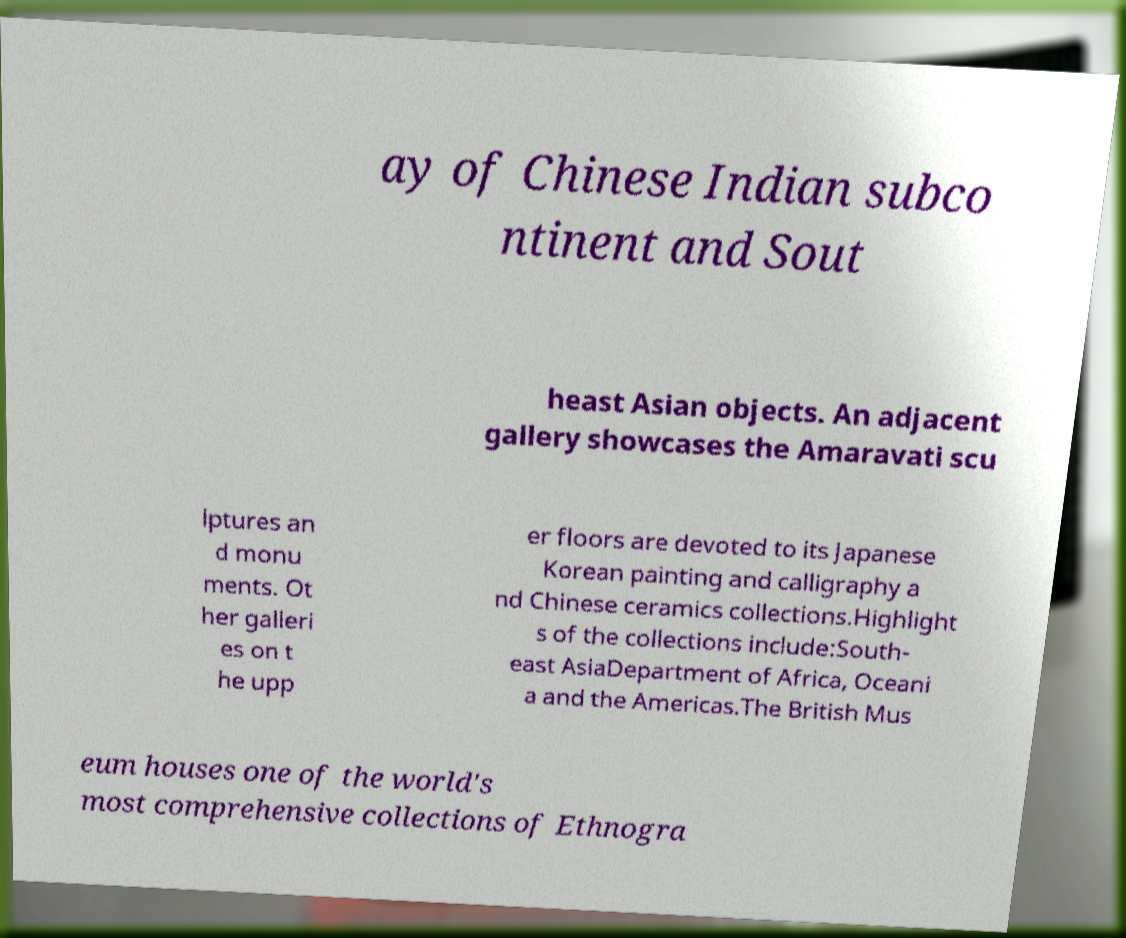Could you extract and type out the text from this image? ay of Chinese Indian subco ntinent and Sout heast Asian objects. An adjacent gallery showcases the Amaravati scu lptures an d monu ments. Ot her galleri es on t he upp er floors are devoted to its Japanese Korean painting and calligraphy a nd Chinese ceramics collections.Highlight s of the collections include:South- east AsiaDepartment of Africa, Oceani a and the Americas.The British Mus eum houses one of the world's most comprehensive collections of Ethnogra 